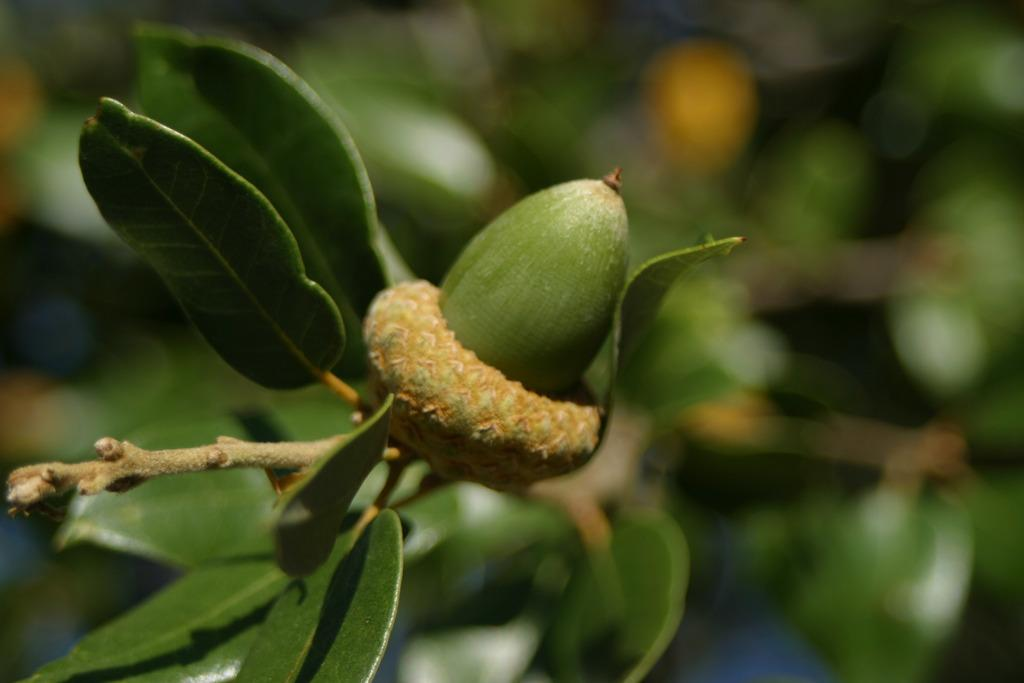What type of living organisms can be seen in the image? The image contains plants. What type of food can be seen in the image? There is a fruit visible in the image. How would you describe the background of the image? The background of the image is blurred. What color are the leaves in the image? Green leaves are present in the image. What type of kitten can be seen playing with a fowl in the image? There is no kitten or fowl present in the image; it only contains plants and a fruit. What is the rate of growth for the plants in the image? The provided facts do not give information about the rate of growth for the plants in the image. 